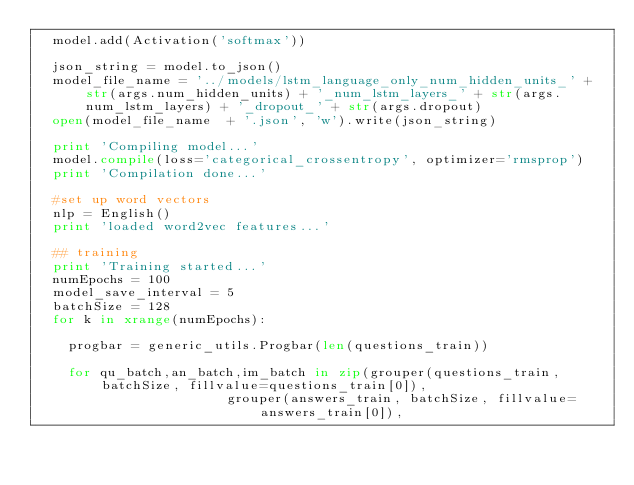Convert code to text. <code><loc_0><loc_0><loc_500><loc_500><_Python_>	model.add(Activation('softmax'))

	json_string = model.to_json()
	model_file_name = '../models/lstm_language_only_num_hidden_units_' + str(args.num_hidden_units) + '_num_lstm_layers_' + str(args.num_lstm_layers) + '_dropout_' + str(args.dropout)
	open(model_file_name  + '.json', 'w').write(json_string)
	
	print 'Compiling model...'
	model.compile(loss='categorical_crossentropy', optimizer='rmsprop')
	print 'Compilation done...'

	#set up word vectors
	nlp = English()
	print 'loaded word2vec features...'

	## training
	print 'Training started...'
	numEpochs = 100
	model_save_interval = 5
	batchSize = 128
	for k in xrange(numEpochs):

		progbar = generic_utils.Progbar(len(questions_train))

		for qu_batch,an_batch,im_batch in zip(grouper(questions_train, batchSize, fillvalue=questions_train[0]), 
												grouper(answers_train, batchSize, fillvalue=answers_train[0]), </code> 